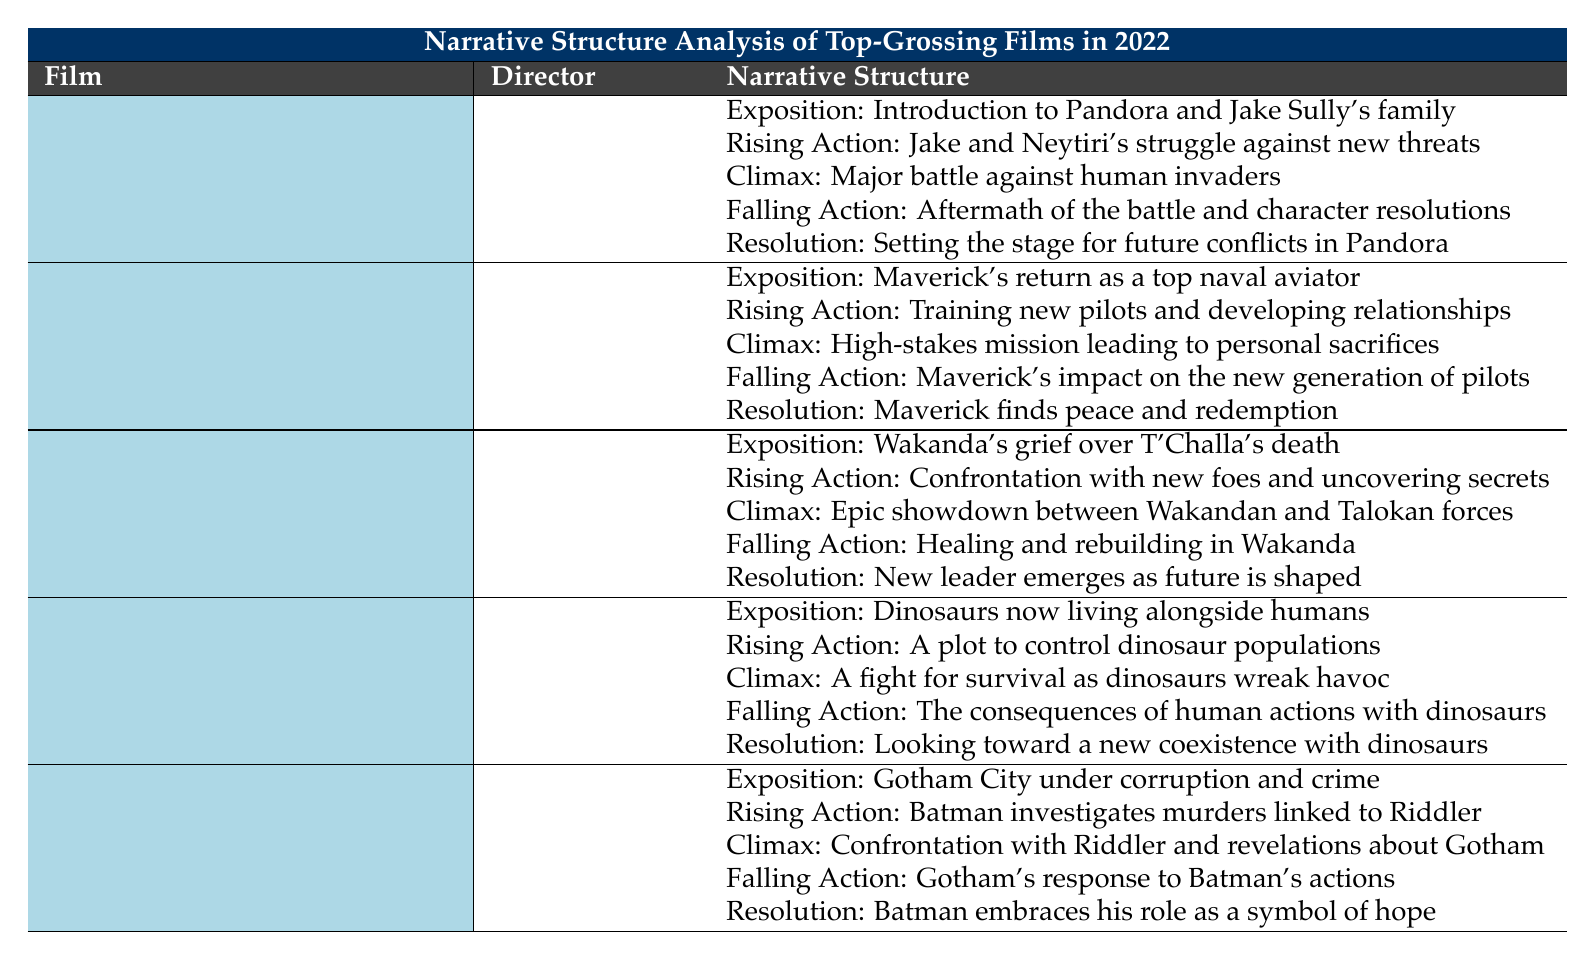What film's climax involves a major battle against human invaders? The climax description for "Avatar: The Way of Water" states that it includes a "major battle against human invaders" which directly answers the question.
Answer: Avatar: The Way of Water Who directed "Top Gun: Maverick"? The table shows that "Top Gun: Maverick" was directed by Joseph Kosinski according to the value listed under the Director column.
Answer: Joseph Kosinski True or False: "Jurassic World Dominion" has a resolution about coexistence with additional dinosaur populations. The resolution for "Jurassic World Dominion" states it is "looking toward a new coexistence with dinosaurs," confirming the statement is true.
Answer: True What genre does "Black Panther: Wakanda Forever" fall under? The genre for "Black Panther: Wakanda Forever" is listed as "Action, Adventure, Sci-Fi," which directly answers the question about its genre.
Answer: Action, Adventure, Sci-Fi What are the rising action components for both "The Batman" and "Top Gun: Maverick"? For "The Batman," the rising action involves "Batman investigates a series of murders linked to Riddler," and for "Top Gun: Maverick," it is "training new pilots and developing relationships." This requires looking at both entries to provide the rising actions.
Answer: Batman investigates a series of murders linked to Riddler; training new pilots and developing relationships Which film features a resolution that describes a new leader emerging? The resolution for "Black Panther: Wakanda Forever" states "new leader emerges as future is shaped," indicating that this film features the described resolution related to leadership.
Answer: Black Panther: Wakanda Forever 